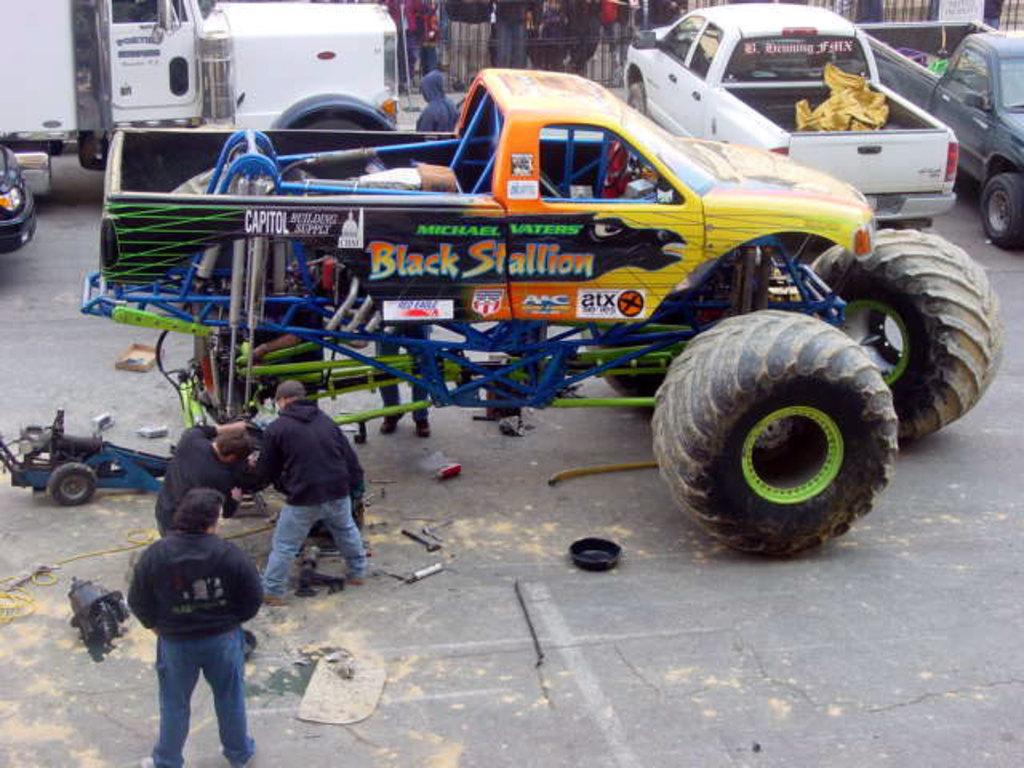<image>
Create a compact narrative representing the image presented. a monster truck with black stallion written on it 